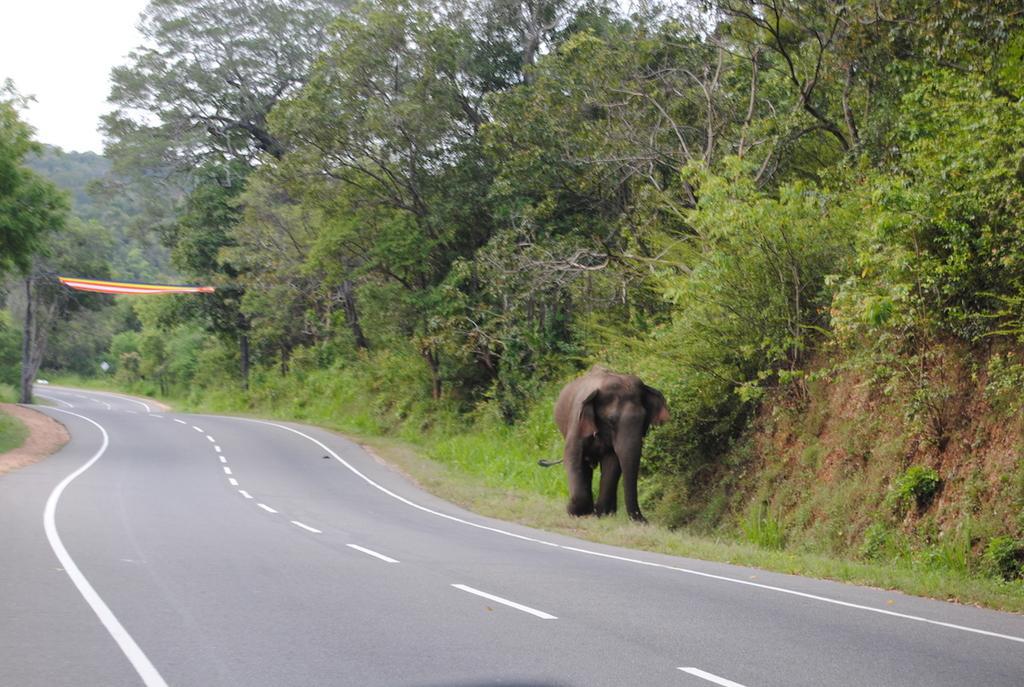Could you give a brief overview of what you see in this image? The picture is taken outside a city. In the foreground of the picture there are plants, grass, road and an elephant. In the center of the picture there are trees, shrubs, road and a cloth. Sky is cloudy. 